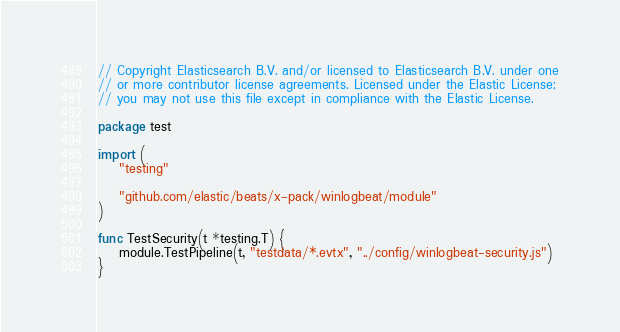<code> <loc_0><loc_0><loc_500><loc_500><_Go_>// Copyright Elasticsearch B.V. and/or licensed to Elasticsearch B.V. under one
// or more contributor license agreements. Licensed under the Elastic License;
// you may not use this file except in compliance with the Elastic License.

package test

import (
	"testing"

	"github.com/elastic/beats/x-pack/winlogbeat/module"
)

func TestSecurity(t *testing.T) {
	module.TestPipeline(t, "testdata/*.evtx", "../config/winlogbeat-security.js")
}
</code> 